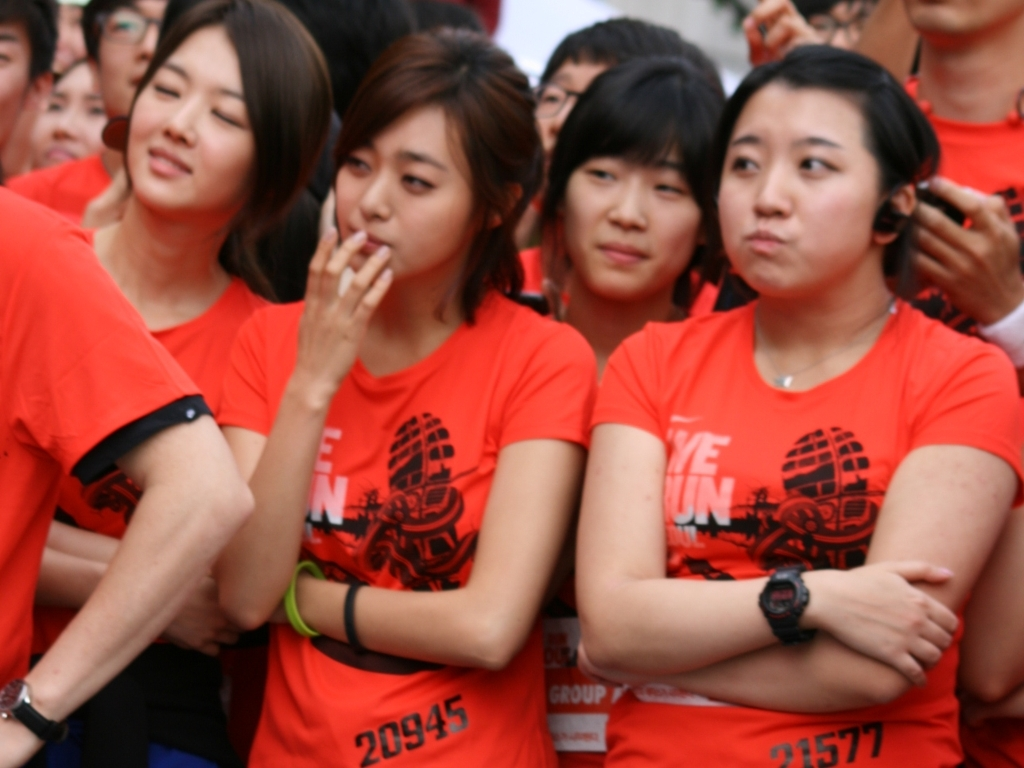Is the clarity of the photo very high? While the photo's clarity is moderately clear, allowing for the identification of individuals and objects, it doesn't reach a high level of clarity which would provide very fine details such as textures and subtle facial expressions. The focus and resolution are somewhat lacking, possibly due to movement or camera settings. 